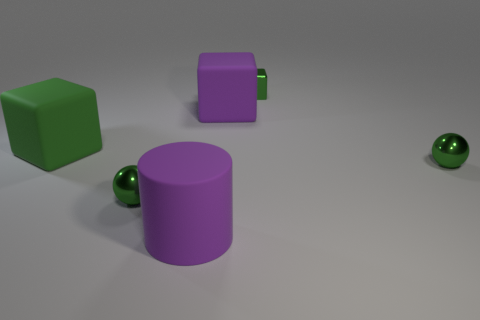There is a large green object; is its shape the same as the big matte thing that is to the right of the purple matte cylinder?
Your answer should be very brief. Yes. What shape is the thing that is the same color as the big rubber cylinder?
Provide a succinct answer. Cube. Is the number of purple cubes that are behind the large green object less than the number of small cyan cylinders?
Your answer should be compact. No. Is the number of tiny blocks less than the number of small cyan matte blocks?
Ensure brevity in your answer.  No. How many big things are either metal blocks or green shiny spheres?
Offer a terse response. 0. What number of objects are both in front of the small metallic block and behind the purple matte cylinder?
Provide a short and direct response. 4. Are there more balls than small blue shiny spheres?
Give a very brief answer. Yes. How many other objects are there of the same shape as the large green rubber object?
Offer a very short reply. 2. What is the object that is on the right side of the green matte block and on the left side of the cylinder made of?
Offer a terse response. Metal. What size is the shiny block?
Provide a succinct answer. Small. 